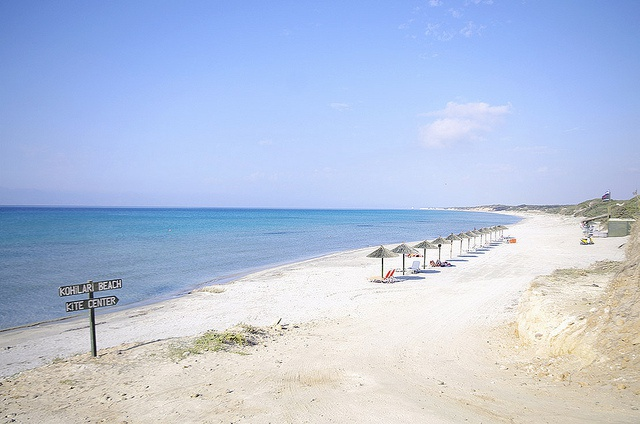Describe the objects in this image and their specific colors. I can see umbrella in gray, darkgray, and lightgray tones, umbrella in gray, darkgray, lightgray, and black tones, umbrella in gray, darkgray, and lightgray tones, umbrella in gray, lightgray, and darkgray tones, and umbrella in gray, darkgray, lightgray, and tan tones in this image. 